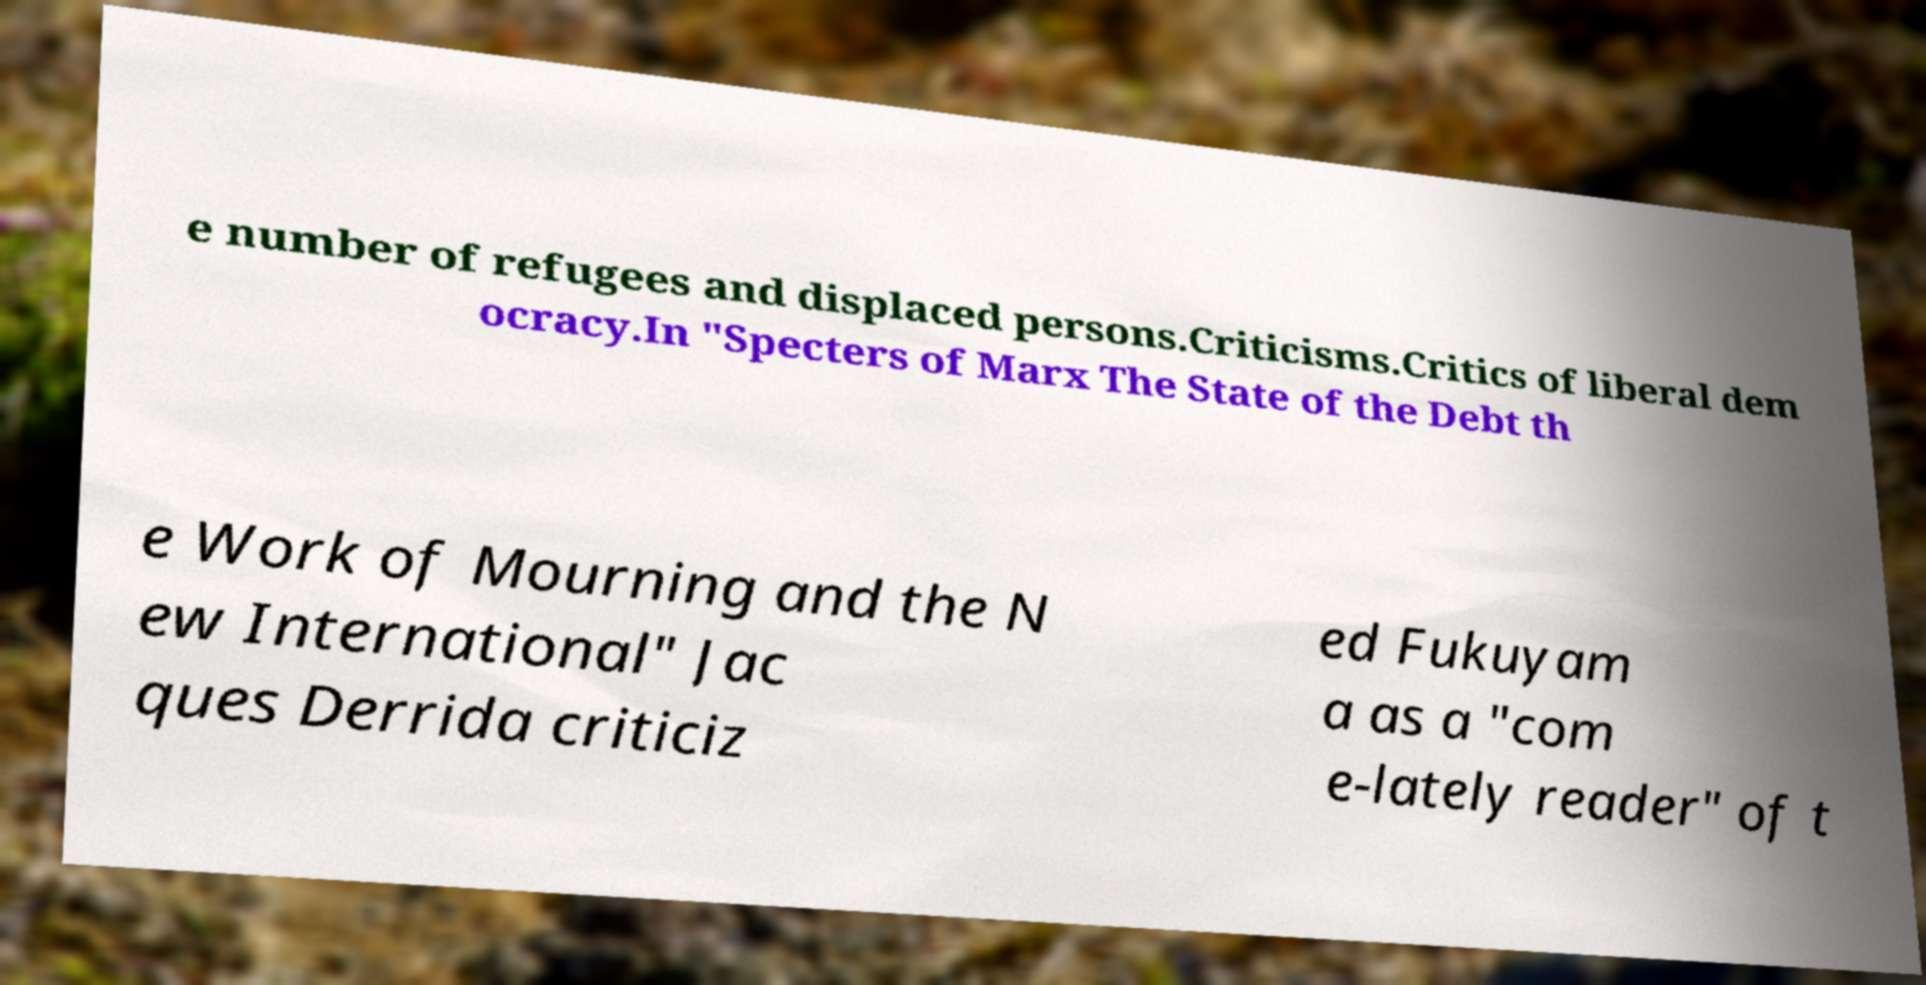For documentation purposes, I need the text within this image transcribed. Could you provide that? e number of refugees and displaced persons.Criticisms.Critics of liberal dem ocracy.In "Specters of Marx The State of the Debt th e Work of Mourning and the N ew International" Jac ques Derrida criticiz ed Fukuyam a as a "com e-lately reader" of t 